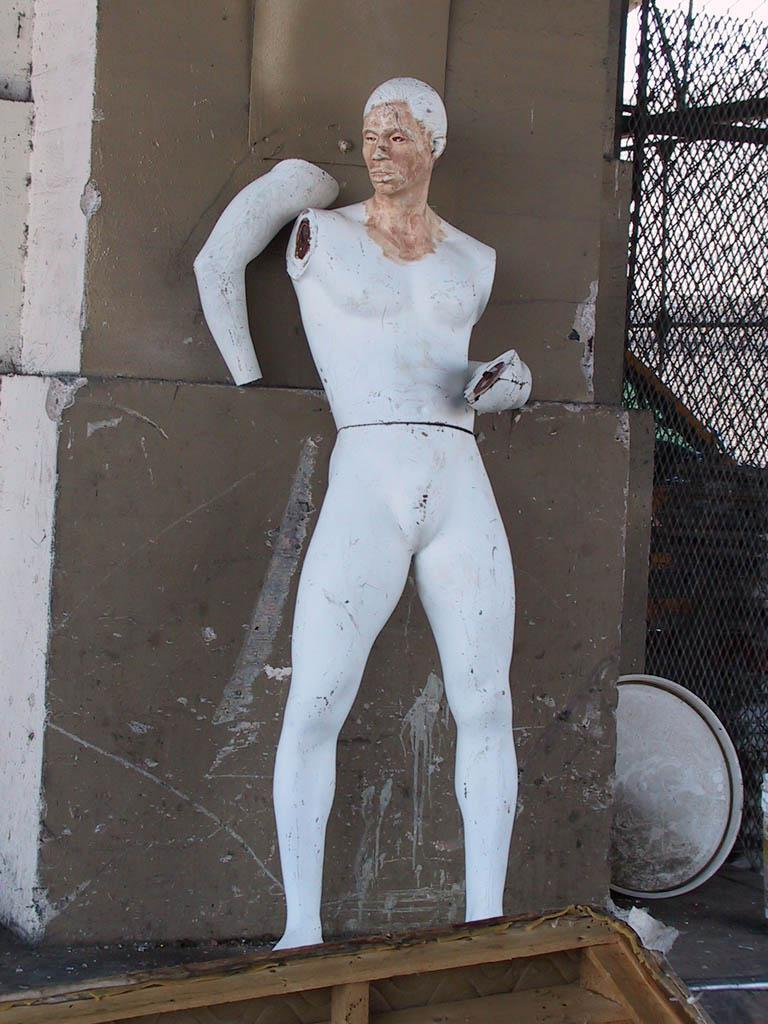What is the main subject of the image? There is a statue of a person in the image. What colors are used for the statue? The statue is in white and brown colors. What can be seen in the background of the image? There is a wall and a net in the background of the image. Where is the statue located in the image? The statue is on an object in the down (possibly a typo, should be "down" or "ground"). How many boats are visible in the image? There are no boats present in the image; it features a statue of a person with a wall and a net in the background. What type of pear is being used to measure the statue's wealth in the image? There is no pear or any reference to wealth in the image; it only shows a statue of a person, a wall, and a net in the background. 